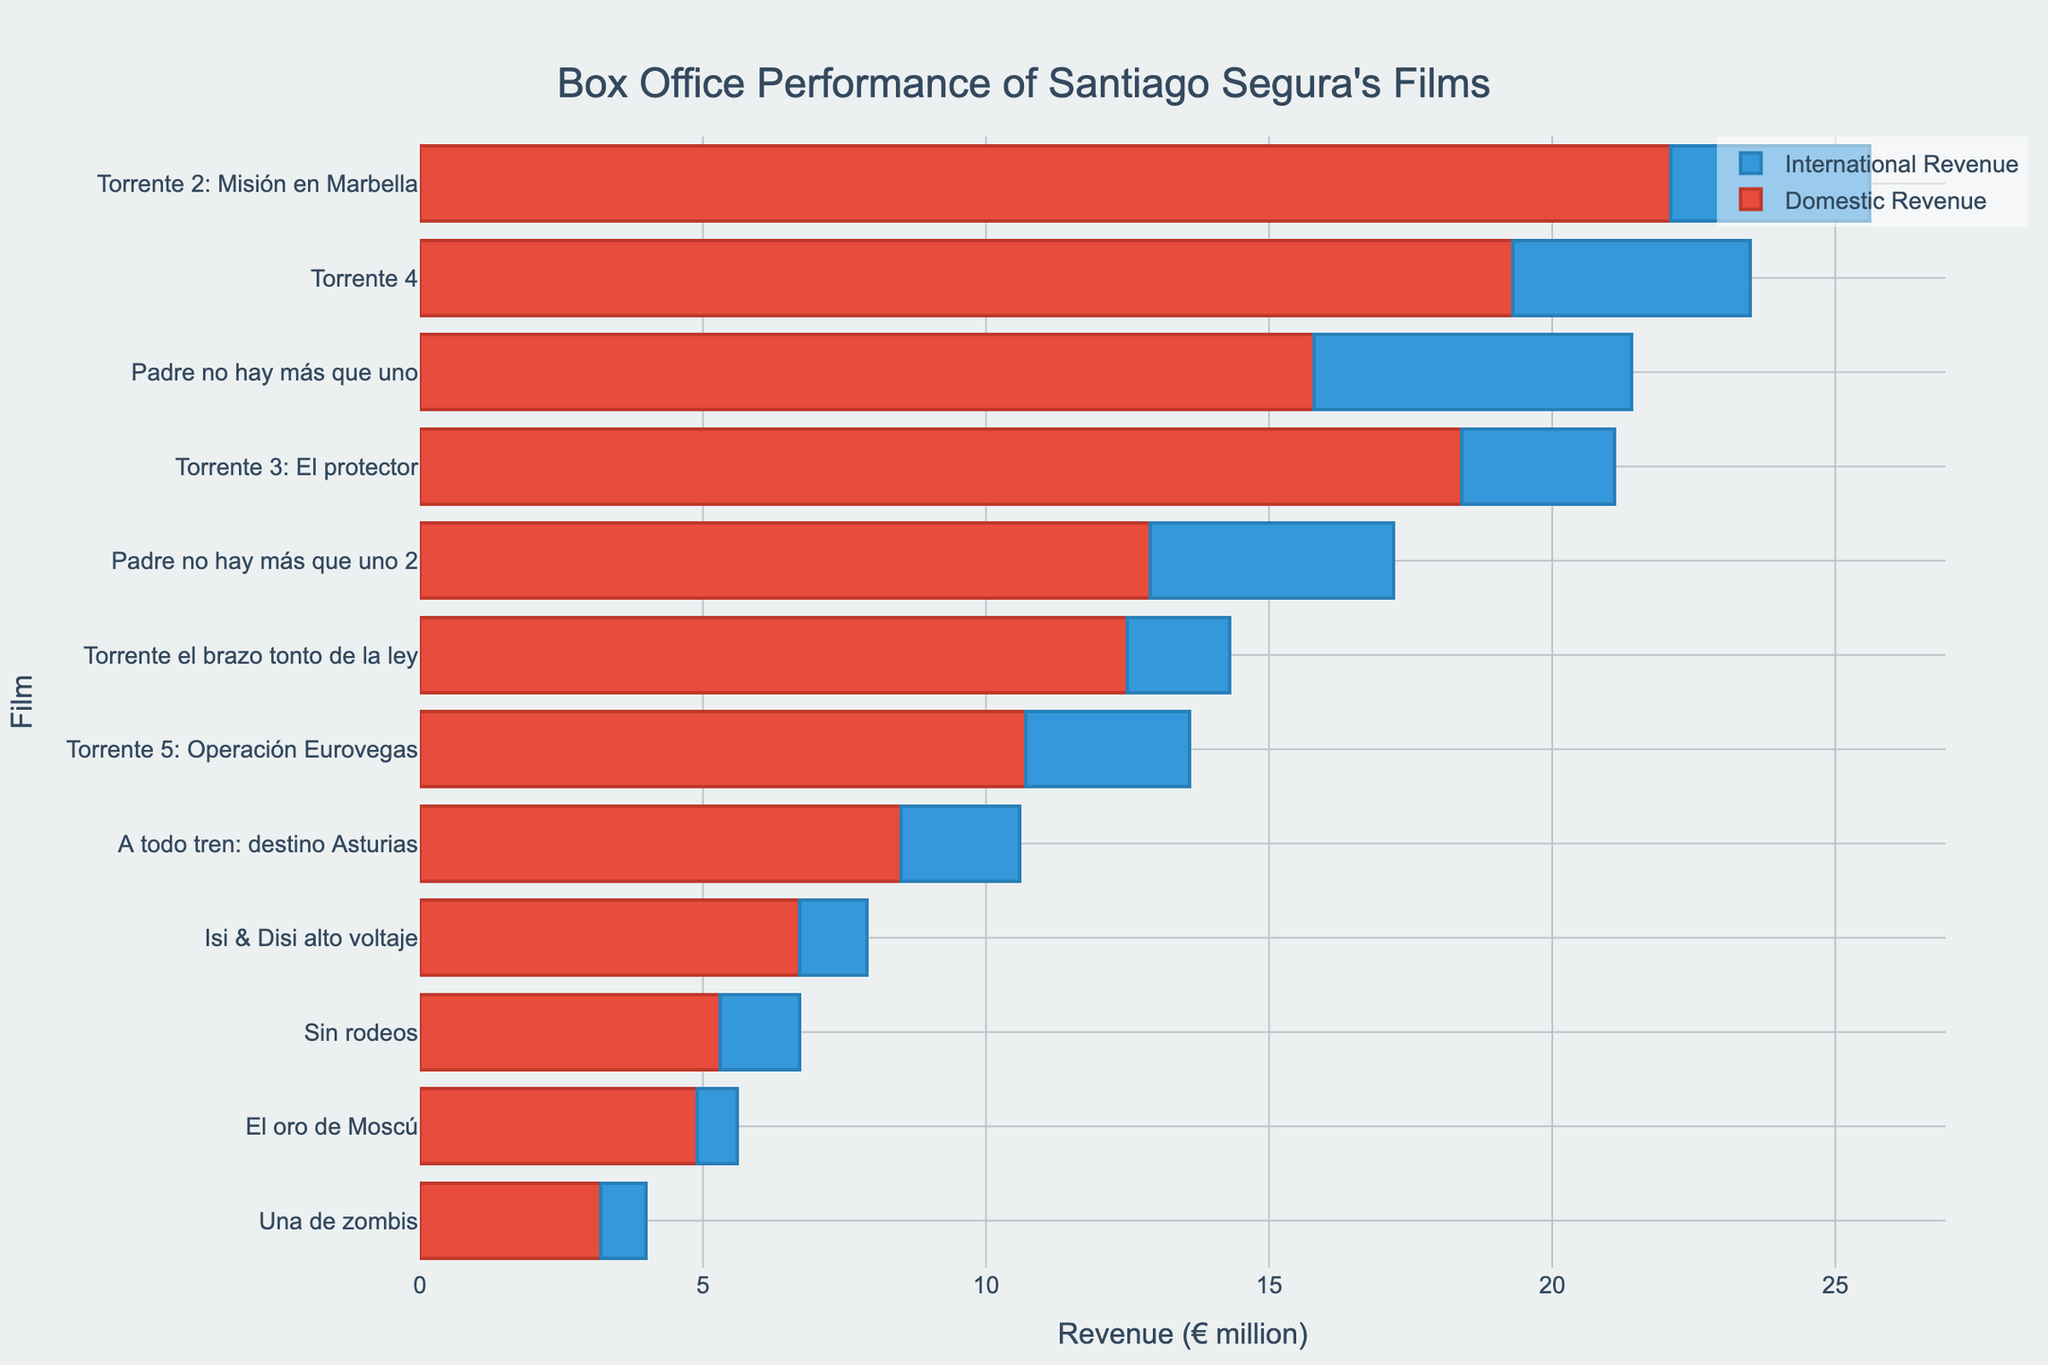Which film had the highest domestic revenue? The bar representing domestic revenue for "Torrente 2: Misión en Marbella" is the longest among all the films.
Answer: Torrente 2: Misión en Marbella Which film had the lowest total revenue? The film with the shortest combination of domestic and international revenue bars is "El oro de Moscú."
Answer: El oro de Moscú How much more was the domestic revenue compared to international revenue for "Padre no hay más que uno"? The domestic revenue for "Padre no hay más que uno" is €15.8 million, while the international revenue is €5.6 million. To find the difference: 15.8 - 5.6 = 10.2
Answer: €10.2 million Which film had the closest international revenue to "Una de zombis"? The international revenue for "Una de zombis" is €0.8 million. Comparing the lengths of the international revenue bars of other films, "El oro de Moscú" also has a similar length bar, representing €0.7 million.
Answer: El oro de Moscú Did "Torrente 4" generate more revenue domestically or internationally? The domestic revenue bar for "Torrente 4" is longer than the international revenue bar, indicating higher domestic revenue.
Answer: Domestically What is the total revenue of "A todo tren: destino Asturias"? The domestic revenue for "A todo tren: destino Asturias" is €8.5 million and the international revenue is €2.1 million. Adding these together gives 8.5 + 2.1 = 10.6
Answer: €10.6 million Which film had the largest difference between domestic and international revenue? The film "Torrente 2: Misión en Marbella" has the largest difference based on the visual length of bars: 22.1 (domestic) - 3.5 (international) = 18.6
Answer: Torrente 2: Misión en Marbella How much total revenue did the Torrente series generate? Summing up the domestic and international revenues for all five Torrente films: 
Torrente 1: 12.5 + 1.8 = 14.3 
Torrente 2: 22.1 + 3.5 = 25.6 
Torrente 3: 18.4 + 2.7 = 21.1 
Torrente 4: 19.3 + 4.2 = 23.5 
Torrente 5: 10.7 + 2.9 = 13.6 
Total: 14.3 + 25.6 + 21.1 + 23.5 + 13.6 = 98.1
Answer: €98.1 million 